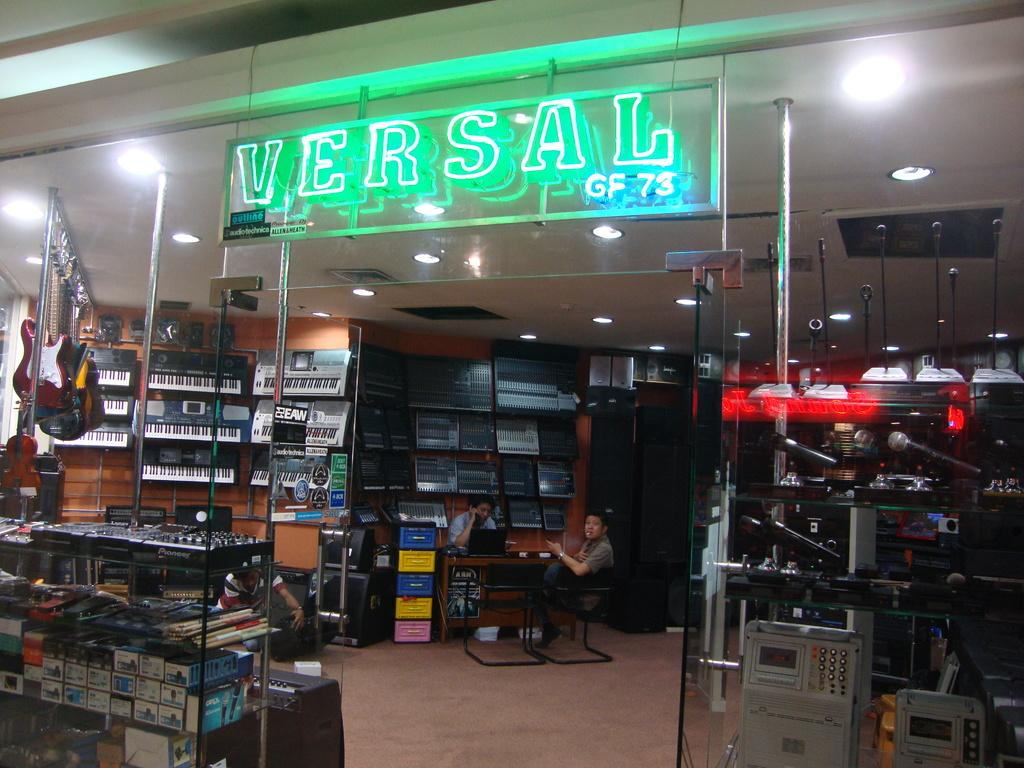<image>
Provide a brief description of the given image. A music store is shown with a neon sign of it's name, Versal, displayed. 